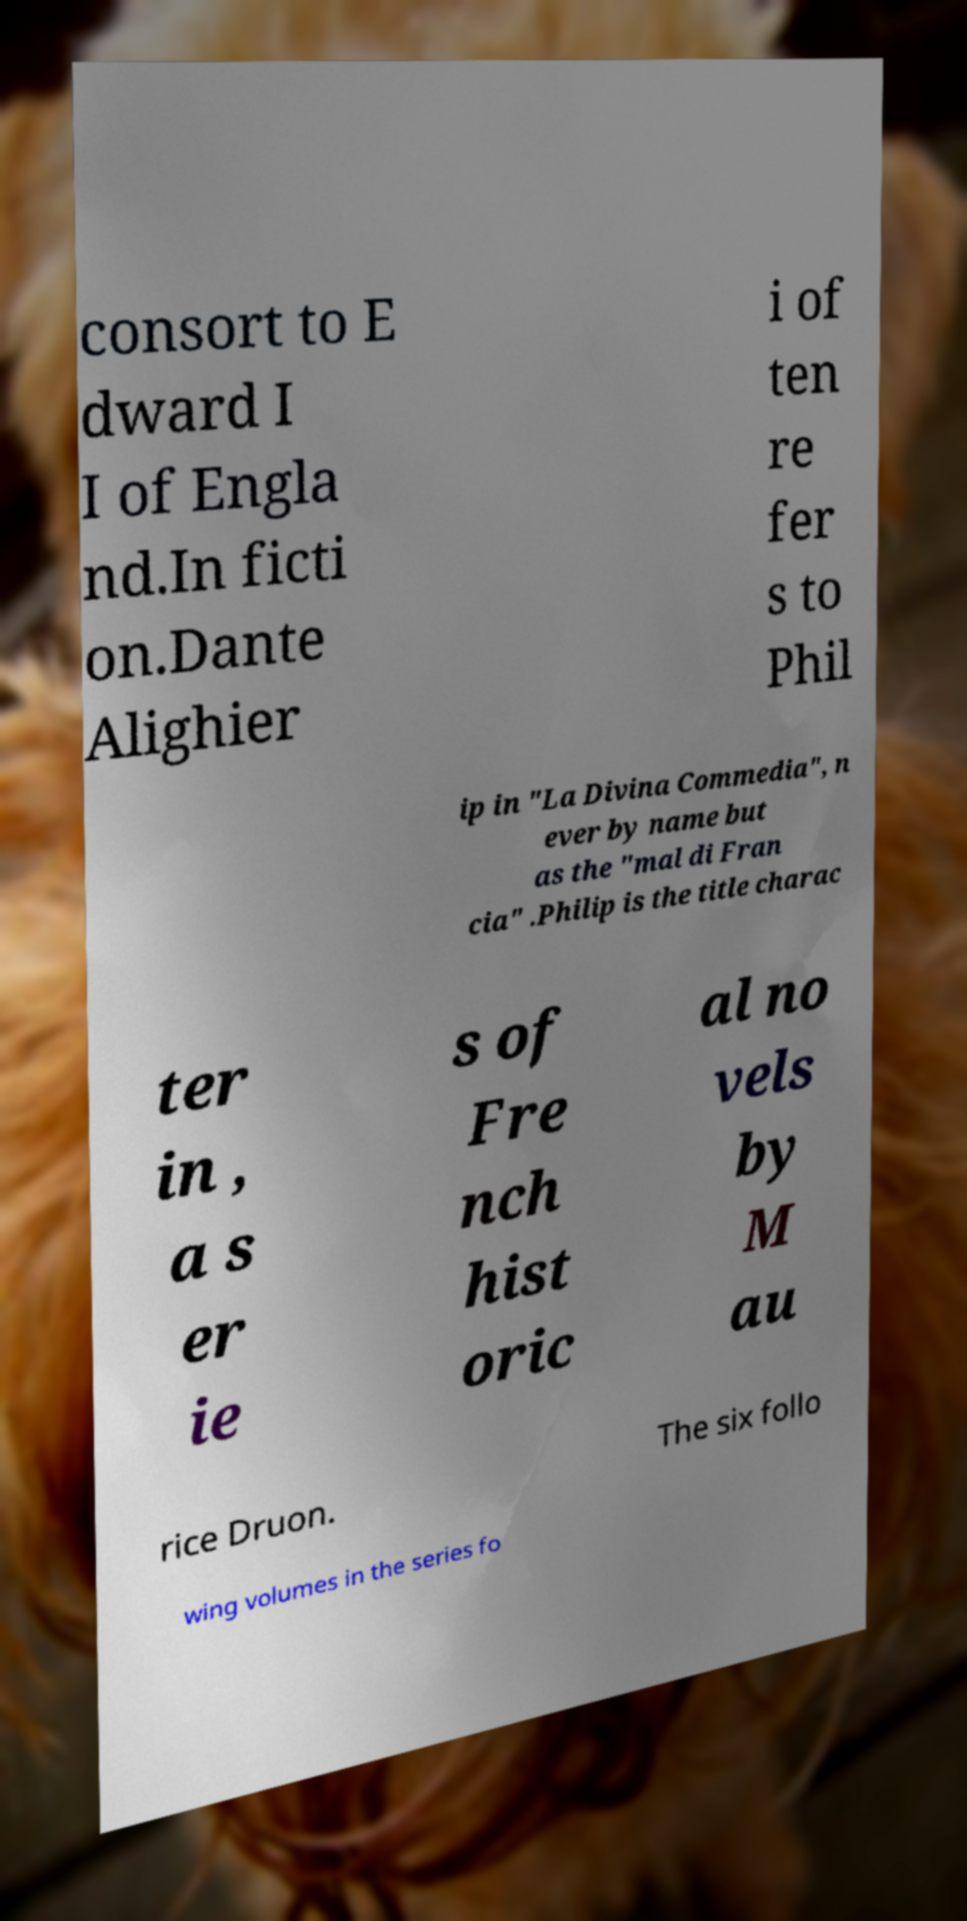Please read and relay the text visible in this image. What does it say? consort to E dward I I of Engla nd.In ficti on.Dante Alighier i of ten re fer s to Phil ip in "La Divina Commedia", n ever by name but as the "mal di Fran cia" .Philip is the title charac ter in , a s er ie s of Fre nch hist oric al no vels by M au rice Druon. The six follo wing volumes in the series fo 